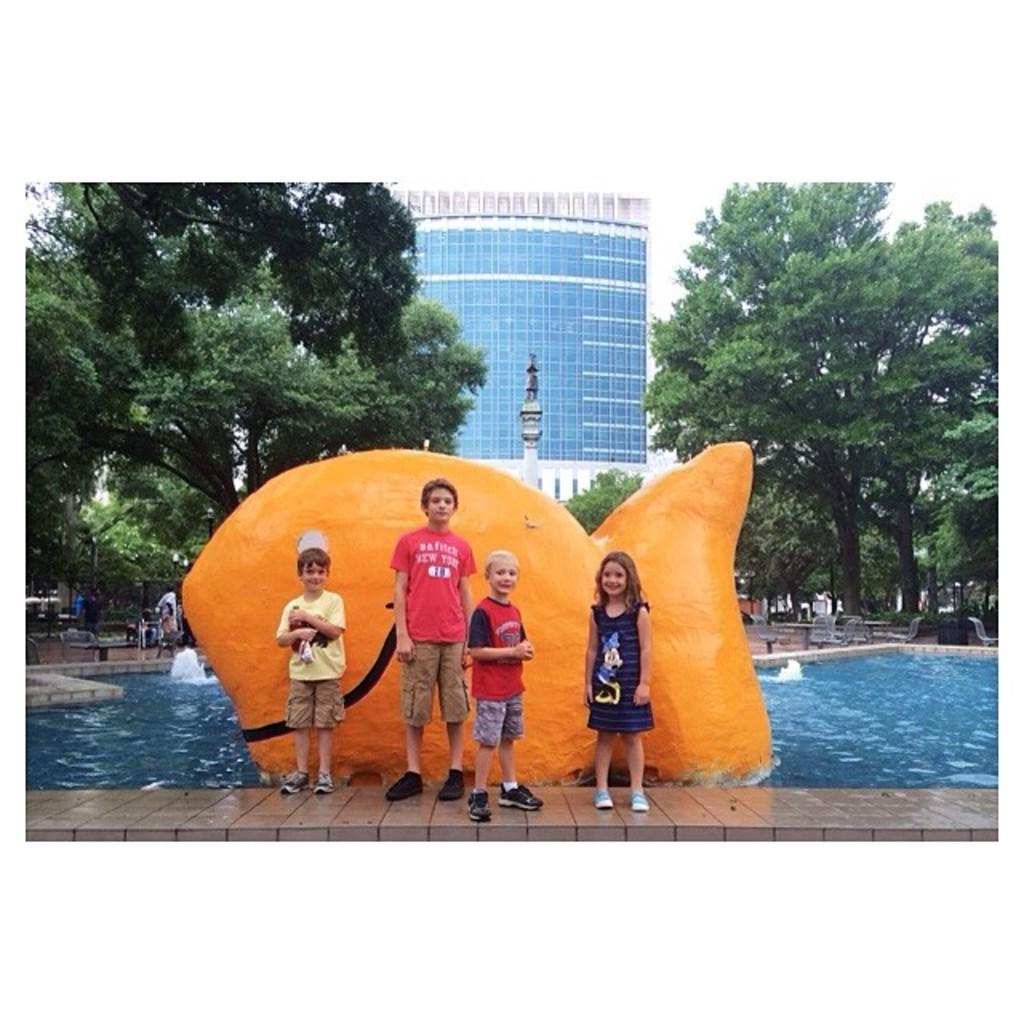What are the main subjects in the center of the image? There are children standing in the center of the image. What can be seen in the background of the image? There is a sculpture and trees in the background of the image. What is located at the bottom of the image? There is a swimming pool at the bottom of the image. What type of structure is visible in the image? There is a building visible in the image. What type of quill is being used by the creator in the image? There is no quill or creator present in the image. How many girls are visible in the image? The image does not specify the gender of the children, so it is not possible to determine the number of girls. 